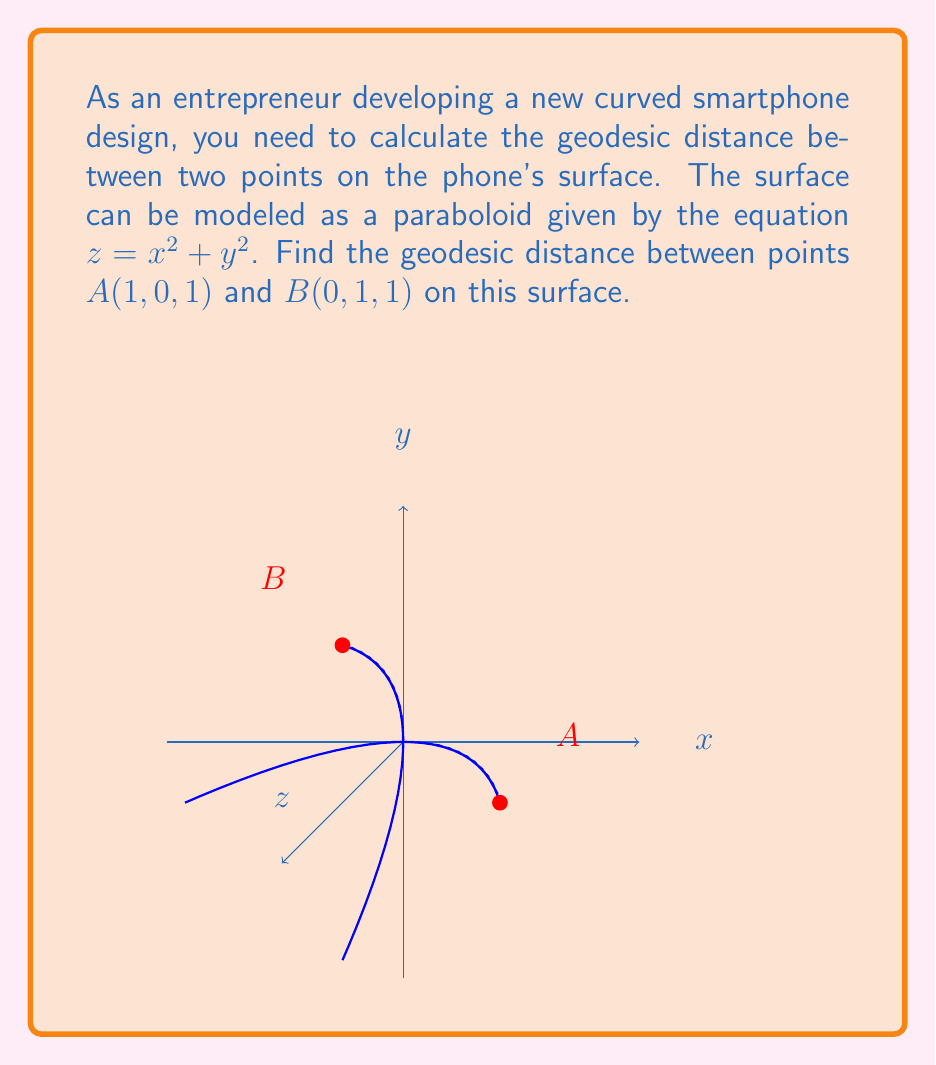Could you help me with this problem? To find the geodesic distance between two points on a curved surface, we need to use the concept of differential geometry. Here's a step-by-step approach:

1) First, we need to parameterize the curve. Let's use $t$ as our parameter, where $0 \leq t \leq 1$. We can represent the curve as:

   $x(t) = 1-t$
   $y(t) = t$
   $z(t) = x(t)^2 + y(t)^2 = (1-t)^2 + t^2$

2) The geodesic distance is given by the integral:

   $$L = \int_0^1 \sqrt{g_{ij} \frac{dx^i}{dt} \frac{dx^j}{dt}} dt$$

   where $g_{ij}$ is the metric tensor.

3) For a surface $z = f(x,y)$, the metric tensor is:

   $$g_{ij} = \begin{pmatrix} 
   1+(\frac{\partial f}{\partial x})^2 & \frac{\partial f}{\partial x}\frac{\partial f}{\partial y} \\
   \frac{\partial f}{\partial x}\frac{\partial f}{\partial y} & 1+(\frac{\partial f}{\partial y})^2
   \end{pmatrix}$$

4) In our case, $\frac{\partial f}{\partial x} = 2x$ and $\frac{\partial f}{\partial y} = 2y$. So:

   $$g_{ij} = \begin{pmatrix} 
   1+4x^2 & 4xy \\
   4xy & 1+4y^2
   \end{pmatrix}$$

5) Now, we need to calculate:

   $$\frac{dx^i}{dt} \frac{dx^j}{dt} = \begin{pmatrix} 
   (\frac{dx}{dt})^2 & \frac{dx}{dt}\frac{dy}{dt} \\
   \frac{dx}{dt}\frac{dy}{dt} & (\frac{dy}{dt})^2
   \end{pmatrix} = \begin{pmatrix} 
   (-1)^2 & (-1)(1) \\
   (-1)(1) & (1)^2
   \end{pmatrix} = \begin{pmatrix} 
   1 & -1 \\
   -1 & 1
   \end{pmatrix}$$

6) The geodesic distance is thus:

   $$L = \int_0^1 \sqrt{(1+4(1-t)^2)(1) + (1+4t^2)(1) - 2(4(1-t)t)(-1)} dt$$

   $$= \int_0^1 \sqrt{2 + 4(1-t)^2 + 4t^2 + 8t(1-t)} dt$$

   $$= \int_0^1 \sqrt{2 + 4} dt = \int_0^1 \sqrt{6} dt = \sqrt{6}$$
Answer: $\sqrt{6}$ 